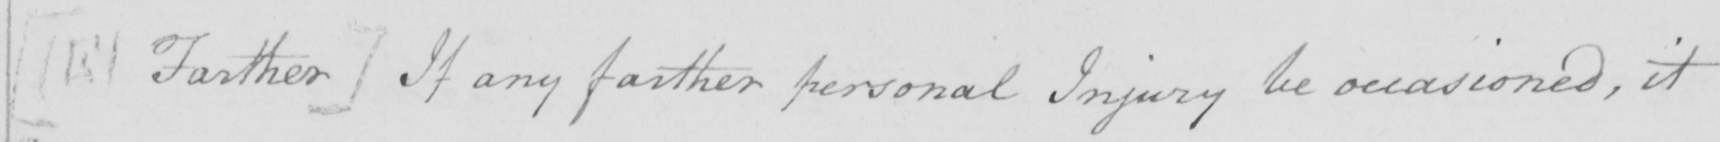Please transcribe the handwritten text in this image. [ E Farther ]  If any further personal Injury be occasioned , it 